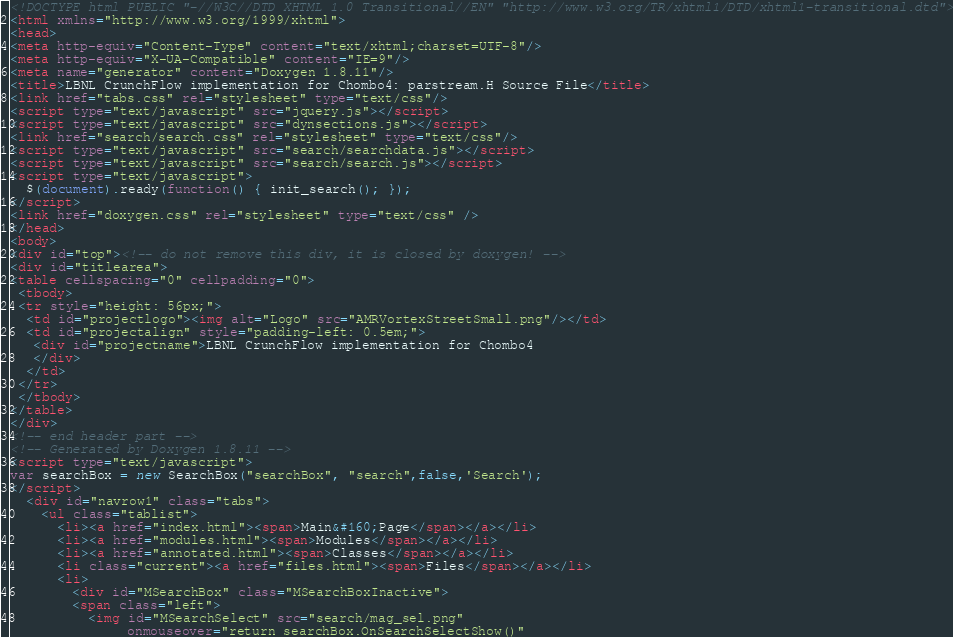Convert code to text. <code><loc_0><loc_0><loc_500><loc_500><_HTML_><!DOCTYPE html PUBLIC "-//W3C//DTD XHTML 1.0 Transitional//EN" "http://www.w3.org/TR/xhtml1/DTD/xhtml1-transitional.dtd">
<html xmlns="http://www.w3.org/1999/xhtml">
<head>
<meta http-equiv="Content-Type" content="text/xhtml;charset=UTF-8"/>
<meta http-equiv="X-UA-Compatible" content="IE=9"/>
<meta name="generator" content="Doxygen 1.8.11"/>
<title>LBNL CrunchFlow implementation for Chombo4: parstream.H Source File</title>
<link href="tabs.css" rel="stylesheet" type="text/css"/>
<script type="text/javascript" src="jquery.js"></script>
<script type="text/javascript" src="dynsections.js"></script>
<link href="search/search.css" rel="stylesheet" type="text/css"/>
<script type="text/javascript" src="search/searchdata.js"></script>
<script type="text/javascript" src="search/search.js"></script>
<script type="text/javascript">
  $(document).ready(function() { init_search(); });
</script>
<link href="doxygen.css" rel="stylesheet" type="text/css" />
</head>
<body>
<div id="top"><!-- do not remove this div, it is closed by doxygen! -->
<div id="titlearea">
<table cellspacing="0" cellpadding="0">
 <tbody>
 <tr style="height: 56px;">
  <td id="projectlogo"><img alt="Logo" src="AMRVortexStreetSmall.png"/></td>
  <td id="projectalign" style="padding-left: 0.5em;">
   <div id="projectname">LBNL CrunchFlow implementation for Chombo4
   </div>
  </td>
 </tr>
 </tbody>
</table>
</div>
<!-- end header part -->
<!-- Generated by Doxygen 1.8.11 -->
<script type="text/javascript">
var searchBox = new SearchBox("searchBox", "search",false,'Search');
</script>
  <div id="navrow1" class="tabs">
    <ul class="tablist">
      <li><a href="index.html"><span>Main&#160;Page</span></a></li>
      <li><a href="modules.html"><span>Modules</span></a></li>
      <li><a href="annotated.html"><span>Classes</span></a></li>
      <li class="current"><a href="files.html"><span>Files</span></a></li>
      <li>
        <div id="MSearchBox" class="MSearchBoxInactive">
        <span class="left">
          <img id="MSearchSelect" src="search/mag_sel.png"
               onmouseover="return searchBox.OnSearchSelectShow()"</code> 